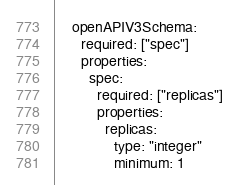Convert code to text. <code><loc_0><loc_0><loc_500><loc_500><_YAML_>    openAPIV3Schema:
      required: ["spec"]
      properties:
        spec:
          required: ["replicas"]
          properties:
            replicas:
              type: "integer"
              minimum: 1</code> 